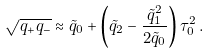<formula> <loc_0><loc_0><loc_500><loc_500>\sqrt { q _ { + } q _ { - } } \approx \tilde { q } _ { 0 } + \left ( \tilde { q } _ { 2 } - \frac { \tilde { q } ^ { 2 } _ { 1 } } { 2 \tilde { q } _ { 0 } } \right ) \tau _ { 0 } ^ { 2 } \, .</formula> 